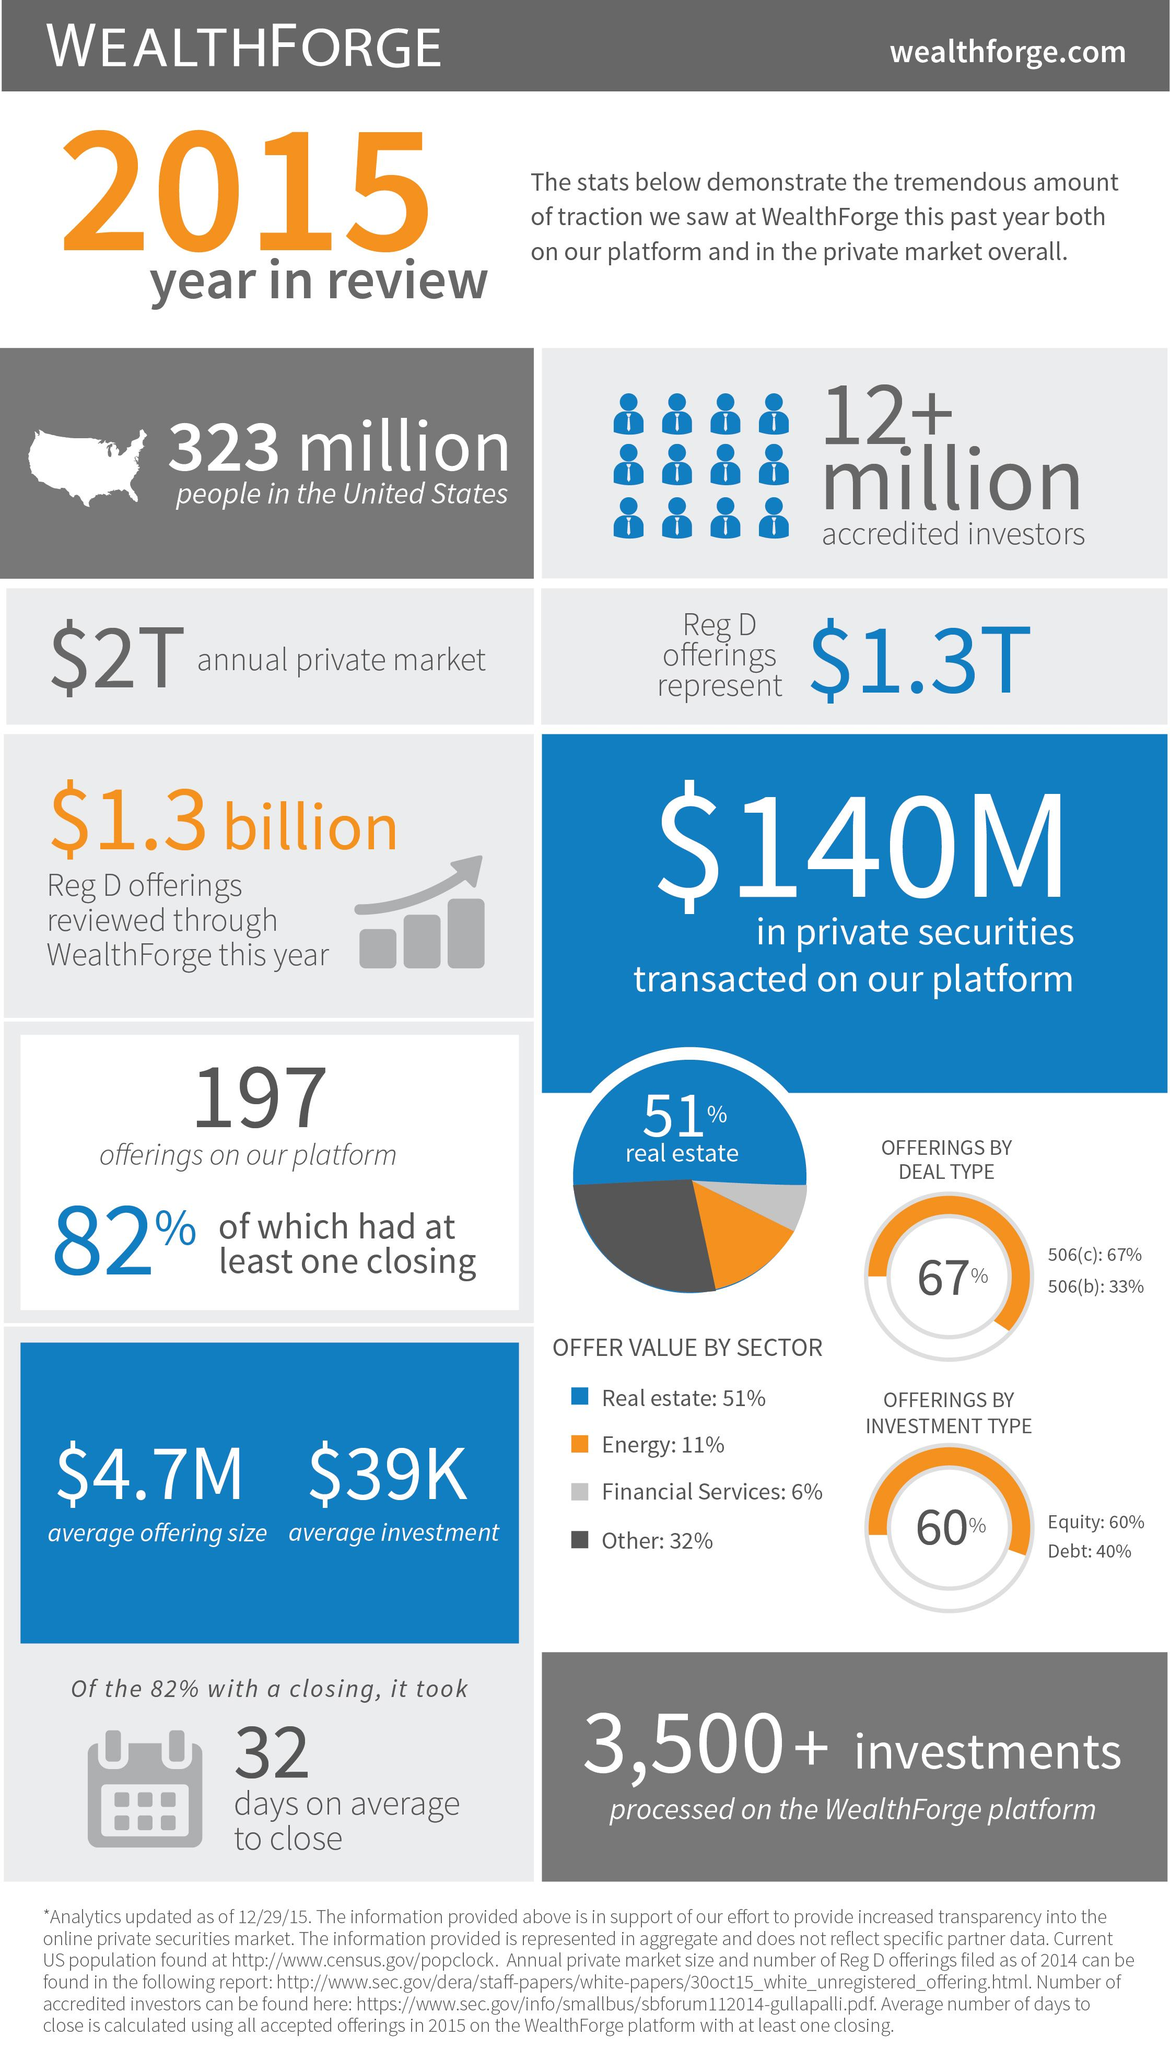Identify some key points in this picture. The real estate sector had the highest offer value. According to our data, 18% of the offerings that were made did not have a closing. 